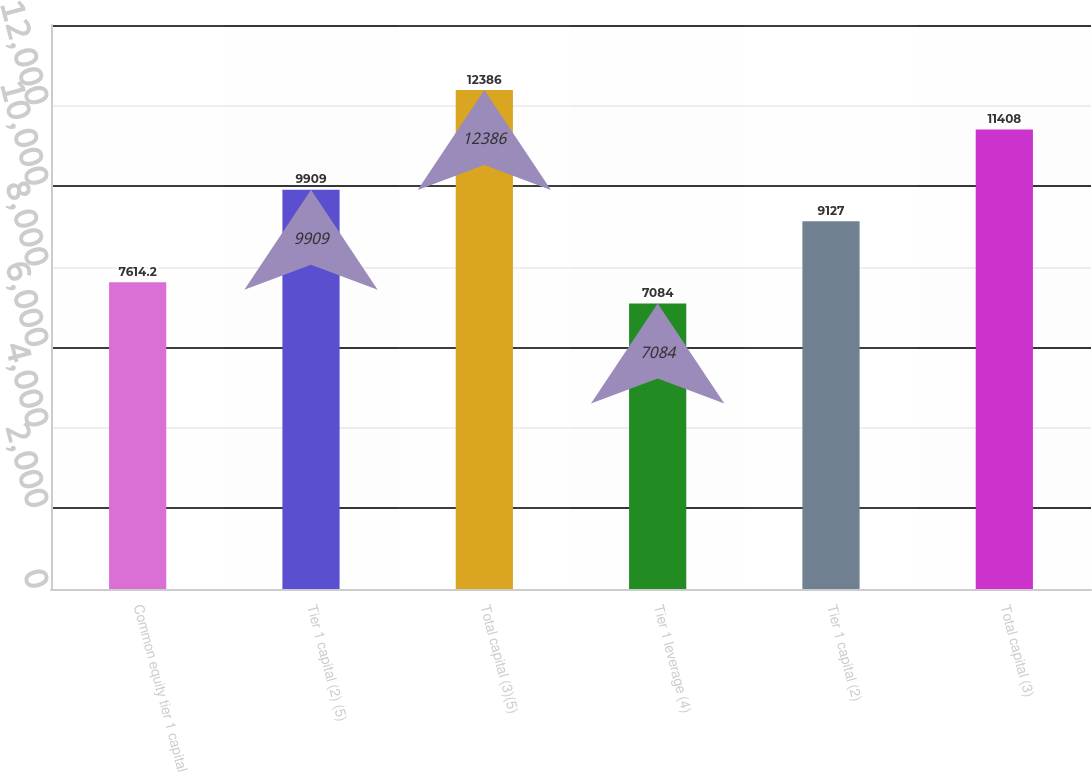Convert chart. <chart><loc_0><loc_0><loc_500><loc_500><bar_chart><fcel>Common equity tier 1 capital<fcel>Tier 1 capital (2) (5)<fcel>Total capital (3)(5)<fcel>Tier 1 leverage (4)<fcel>Tier 1 capital (2)<fcel>Total capital (3)<nl><fcel>7614.2<fcel>9909<fcel>12386<fcel>7084<fcel>9127<fcel>11408<nl></chart> 